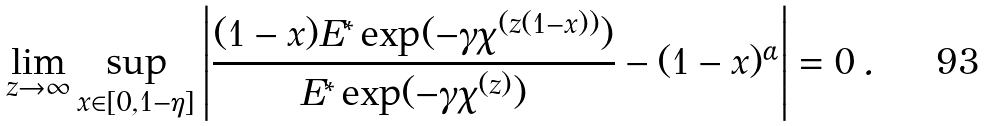<formula> <loc_0><loc_0><loc_500><loc_500>\lim _ { z \to \infty } \sup _ { x \in [ 0 , 1 - \eta ] } \left | \frac { ( 1 - x ) E ^ { \ast } \exp ( - \gamma \chi ^ { ( z ( 1 - x ) ) } ) } { E ^ { \ast } \exp ( - \gamma \chi ^ { ( z ) } ) } - ( 1 - x ) ^ { \alpha } \right | = 0 \, .</formula> 